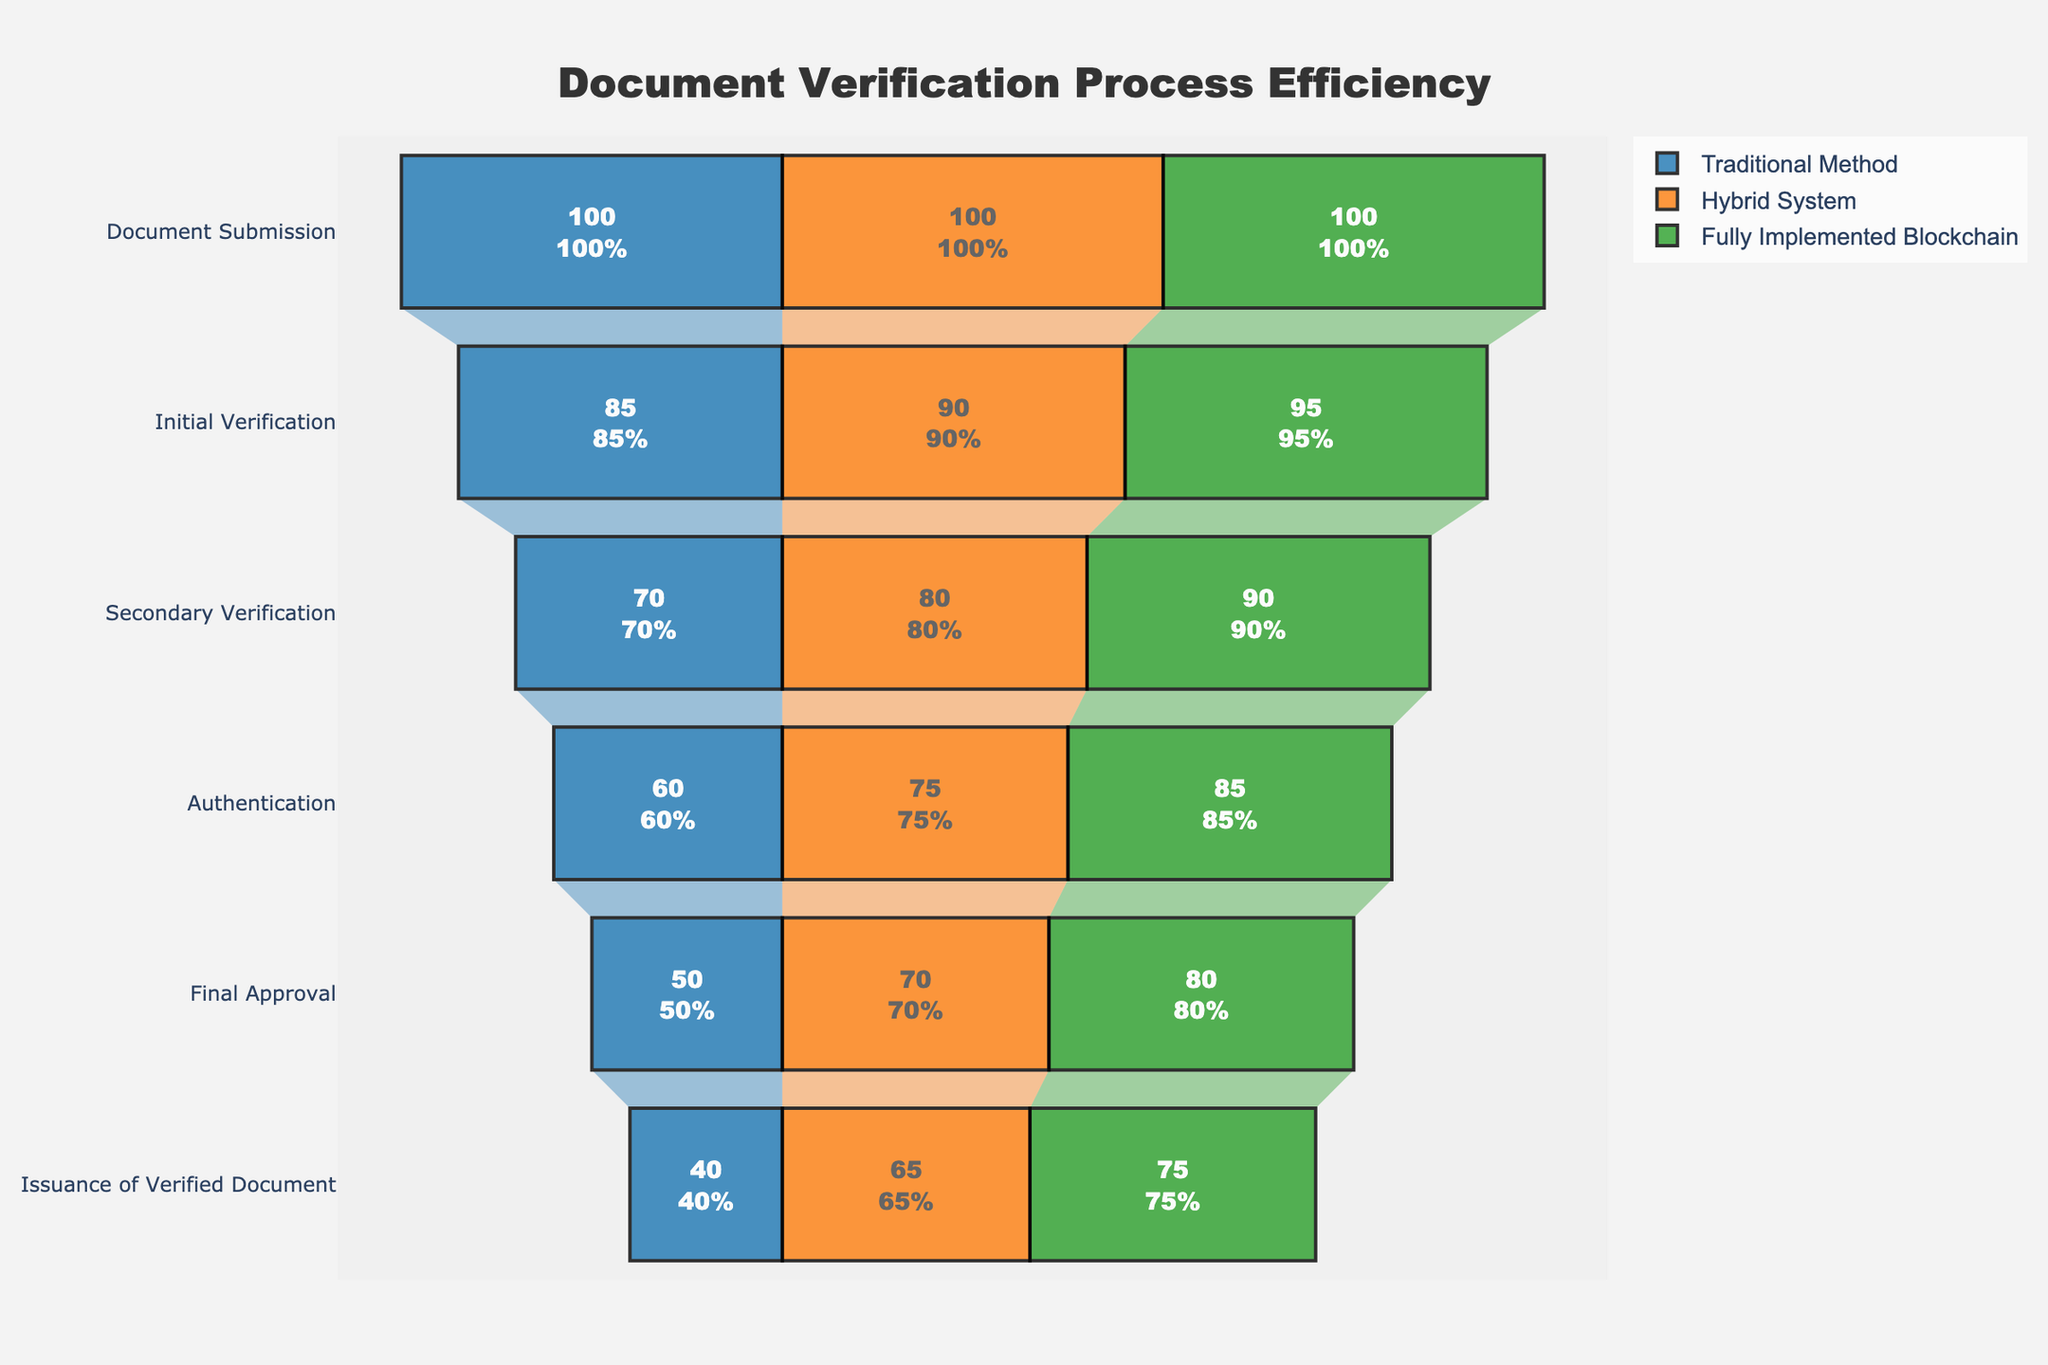What is the overall title of the figure? The overall title is displayed at the top of the funnel chart, centered, and generally had a larger font size for emphasis. It reads "Document Verification Process Efficiency".
Answer: Document Verification Process Efficiency How many steps are there in the document verification process according to the chart? The vertical axis lists all the steps involved in the document verification process, with each unique step clearly labeled. Counting these labels confirms the total number of steps.
Answer: Six At which step does the 'Hybrid System' have the greatest efficiency percentage drop compared to the 'Fully Implemented Blockchain'? To identify this, compare the percentage for each step between the 'Hybrid System' and 'Fully Implemented Blockchain'. The largest drop is found when the difference is maximum.
Answer: Document Submission to Initial Verification What is the efficiency percentage for 'Initial Verification' in a 'Fully Implemented Blockchain' system? Find the label 'Initial Verification' on the y-axis, then trace horizontally to the value displayed for the 'Fully Implemented Blockchain' system, marked by the green color on the funnel.
Answer: 95% What is the difference in the issuance of verified document efficiency between the 'Traditional Method' and the 'Hybrid System'? Locate the 'Issuance of Verified Document' step on the y-axis and compare the corresponding efficiency percentages for the 'Traditional Method' and 'Hybrid System'. Subtract the 'Traditional Method' percentage from the 'Hybrid System' percentage.
Answer: 65% - 40% = 25% Describe the color scheme used for each system in the chart. Each system uses a different color to differentiate it. Traditional Method is blue, Hybrid System is orange, and Fully Implemented Blockchain is green.
Answer: Blue, Orange, Green Which system shows consistent improvements across all steps of the document verification process? By observing and comparing the efficiency percentages step-by-step for each system, you can notice that one system consistently has higher values. The 'Fully Implemented Blockchain' system appears to have improving values at each step compared to the other systems.
Answer: Fully Implemented Blockchain Between the 'Secondary Verification' and 'Authentication' steps, which step has a greater percentage drop in the 'Traditional Method'? Compare the efficiency percentages from Secondary Verification to Authentication in the Traditional Method. The step with a larger difference in percentage values indicates a greater drop.
Answer: Secondary Verification (70%) to Authentication (60%) Is the 'Final Approval' step more efficient in the 'Hybrid System' or the 'Fully Implemented Blockchain' system? By how much? Examine the efficiency percentages for 'Final Approval' in both the Hybrid System and the Fully Implemented Blockchain. The one with a higher percentage is more efficient, and the difference between them equals the 'how much'.
Answer: Fully Implemented Blockchain by 10% How does the authentication efficiency of the 'Traditional Method' compare to the 'Hybrid System'? Find the 'Authentication' step on the y-axis and observe the percentages for both Traditional Method and Hybrid System. Compare these values directly to determine how they differ.
Answer: Traditional Method (60%), Hybrid System (75%) 